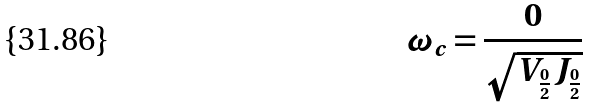<formula> <loc_0><loc_0><loc_500><loc_500>\omega _ { c } = \frac { 0 } { \sqrt { V _ { \frac { 0 } { 2 } } J _ { \frac { 0 } { 2 } } } }</formula> 